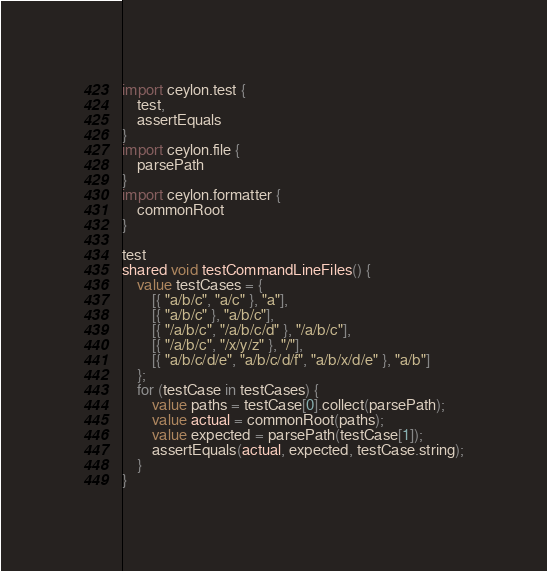Convert code to text. <code><loc_0><loc_0><loc_500><loc_500><_Ceylon_>import ceylon.test {
    test,
    assertEquals
}
import ceylon.file {
    parsePath
}
import ceylon.formatter {
    commonRoot
}

test
shared void testCommandLineFiles() {
    value testCases = {
        [{ "a/b/c", "a/c" }, "a"],
        [{ "a/b/c" }, "a/b/c"],
        [{ "/a/b/c", "/a/b/c/d" }, "/a/b/c"],
        [{ "/a/b/c", "/x/y/z" }, "/"],
        [{ "a/b/c/d/e", "a/b/c/d/f", "a/b/x/d/e" }, "a/b"]
    };
    for (testCase in testCases) {
        value paths = testCase[0].collect(parsePath);
        value actual = commonRoot(paths);
        value expected = parsePath(testCase[1]);
        assertEquals(actual, expected, testCase.string);
    }
}
</code> 